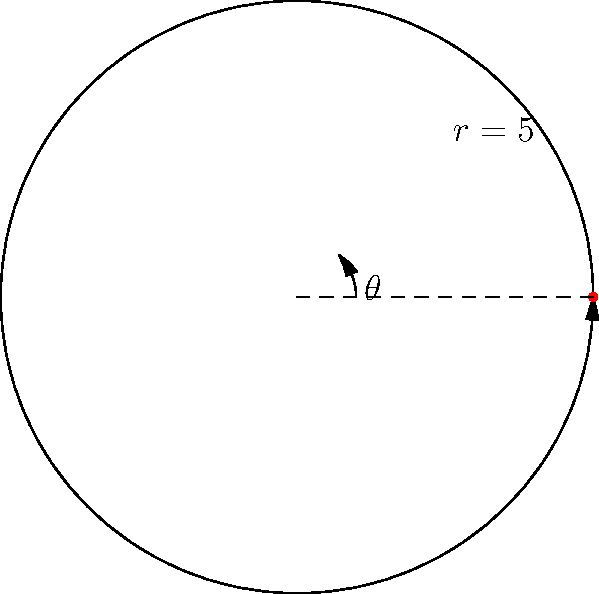You're designing a rotating spice rack for your kitchen to organize ingredients for quick weeknight meals. The rack has a circular shape with a radius of 5 inches. If you want to place 8 evenly spaced spice jars around the edge of the rack, what is the polar coordinate angle (in radians) between each jar? To find the angle between each spice jar, we can follow these steps:

1. Recall that a full circle contains $2\pi$ radians or 360°.

2. Since we want to place 8 evenly spaced jars, we need to divide the full circle into 8 equal parts.

3. The angle between each jar can be calculated as:
   $$\text{Angle} = \frac{\text{Total angle}}{\text{Number of jars}}$$

4. Substituting the values:
   $$\text{Angle} = \frac{2\pi}{8}$$

5. Simplify:
   $$\text{Angle} = \frac{\pi}{4} \text{ radians}$$

This angle, $\frac{\pi}{4}$ radians, is equivalent to 45° and represents the spacing between each spice jar on your rotating rack.
Answer: $\frac{\pi}{4}$ radians 